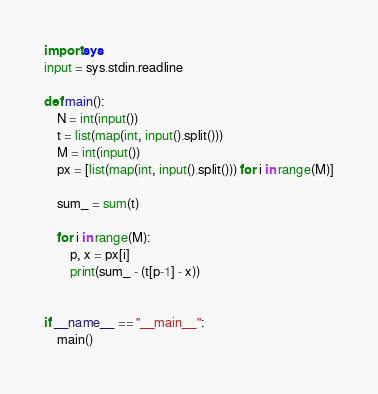Convert code to text. <code><loc_0><loc_0><loc_500><loc_500><_Python_>import sys
input = sys.stdin.readline

def main():
    N = int(input())
    t = list(map(int, input().split()))
    M = int(input())
    px = [list(map(int, input().split())) for i in range(M)]

    sum_ = sum(t)

    for i in range(M):
        p, x = px[i]
        print(sum_ - (t[p-1] - x))


if __name__ == "__main__":
    main()</code> 